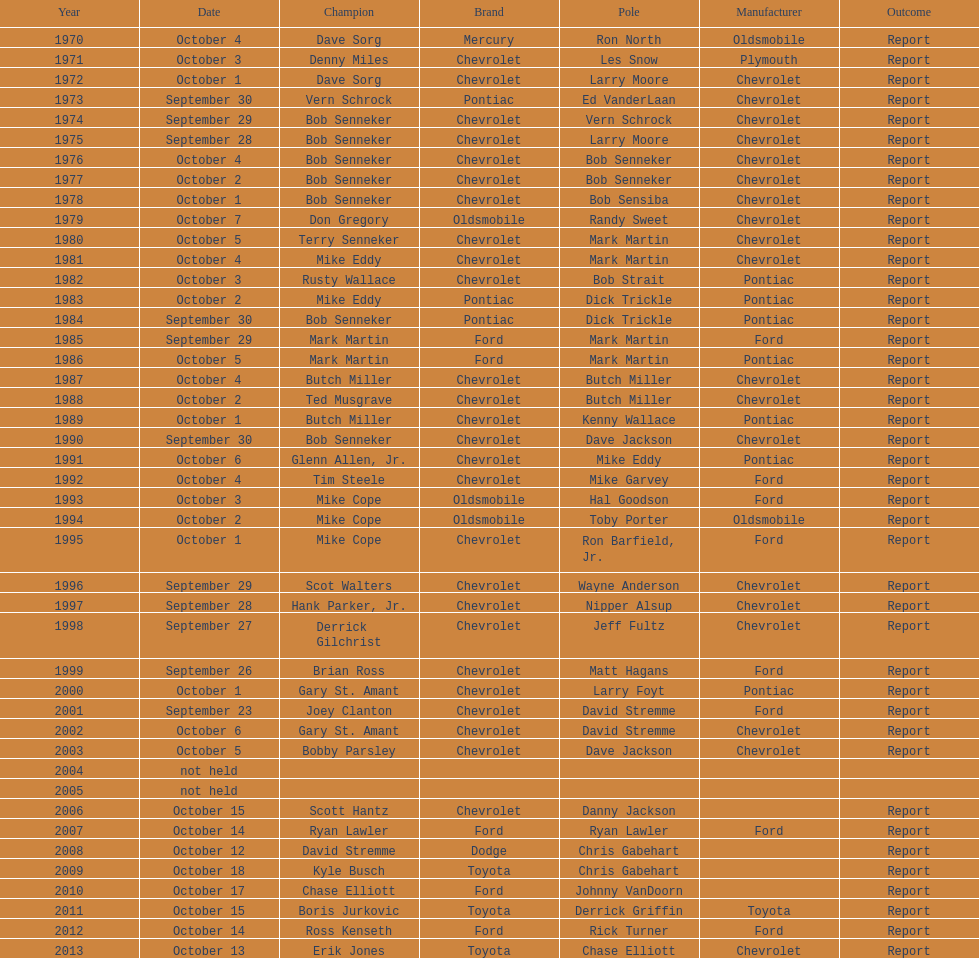Which make of car was used the least by those that won races? Toyota. 